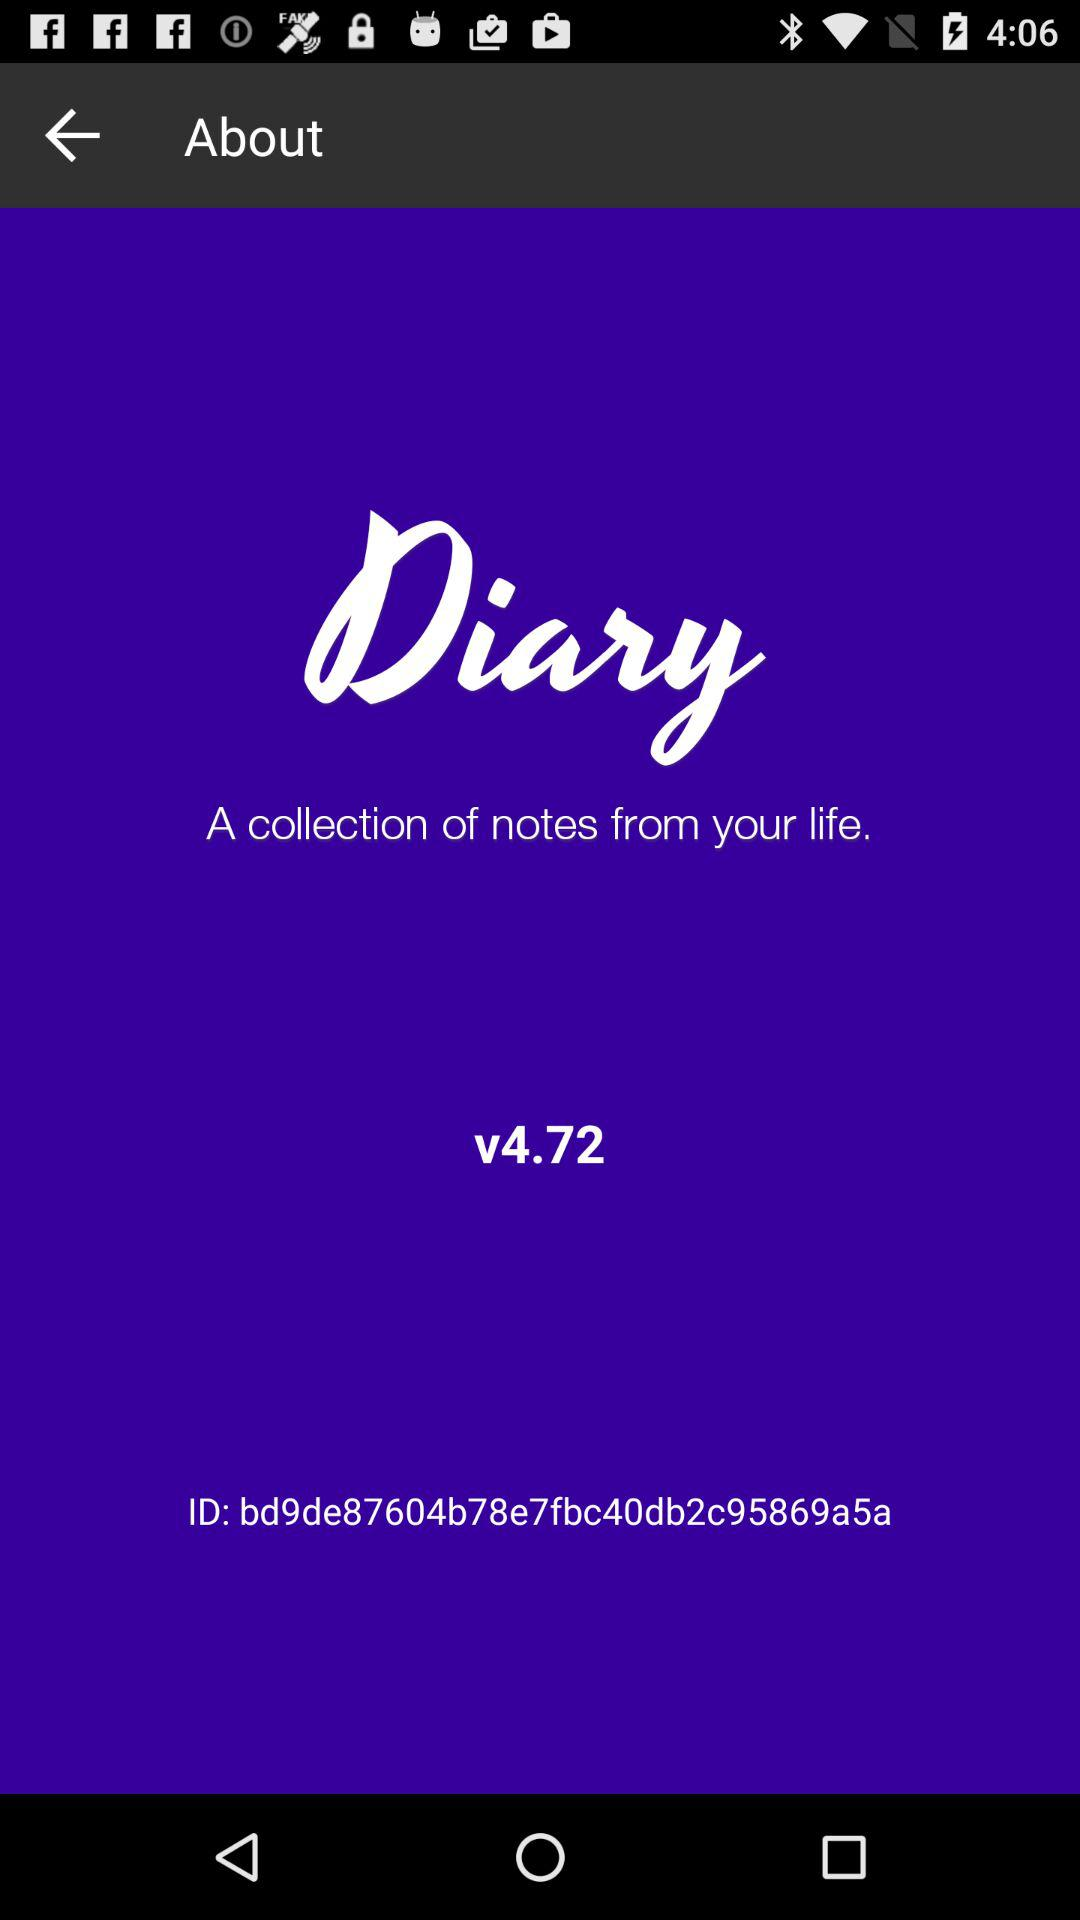Can you describe what features might be available in this application? Given that 'Diary' is geared towards managing personal notes, likely features could include creating, editing, and organizing entries by date or topic, search functionality to easily find past entries, and possibly security measures like a password or encryption to keep the notes private. 